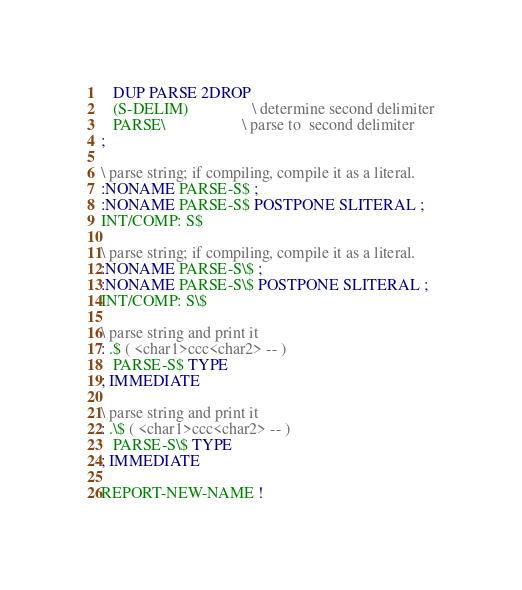<code> <loc_0><loc_0><loc_500><loc_500><_Forth_>   DUP PARSE 2DROP
   (S-DELIM)                \ determine second delimiter
   PARSE\                   \ parse to  second delimiter
;

\ parse string; if compiling, compile it as a literal.
:NONAME PARSE-S$ ;
:NONAME PARSE-S$ POSTPONE SLITERAL ;
INT/COMP: S$

\ parse string; if compiling, compile it as a literal.
:NONAME PARSE-S\$ ;
:NONAME PARSE-S\$ POSTPONE SLITERAL ;
INT/COMP: S\$

\ parse string and print it
: .$ ( <char1>ccc<char2> -- )
   PARSE-S$ TYPE
; IMMEDIATE

\ parse string and print it
: .\$ ( <char1>ccc<char2> -- )
   PARSE-S\$ TYPE
; IMMEDIATE

REPORT-NEW-NAME !
</code> 